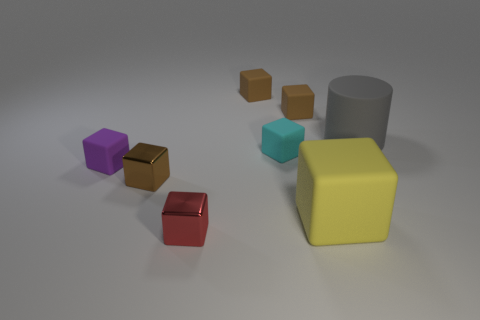Subtract all purple cylinders. How many brown cubes are left? 3 Subtract 2 blocks. How many blocks are left? 5 Subtract all brown rubber blocks. How many blocks are left? 5 Subtract all yellow cubes. How many cubes are left? 6 Subtract all purple blocks. Subtract all gray cylinders. How many blocks are left? 6 Add 1 brown blocks. How many objects exist? 9 Subtract all cylinders. How many objects are left? 7 Add 7 tiny brown cubes. How many tiny brown cubes exist? 10 Subtract 1 red blocks. How many objects are left? 7 Subtract all tiny cyan things. Subtract all brown shiny blocks. How many objects are left? 6 